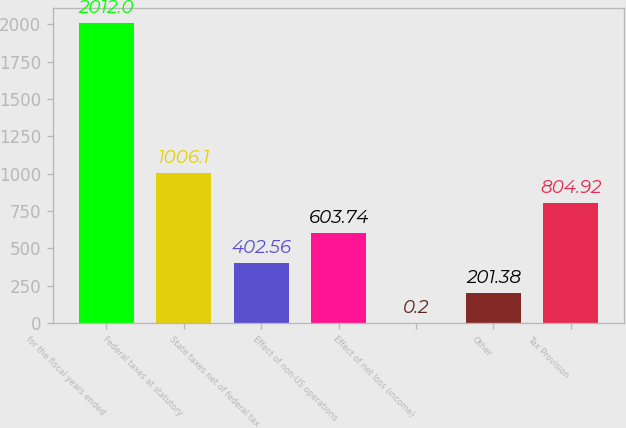Convert chart to OTSL. <chart><loc_0><loc_0><loc_500><loc_500><bar_chart><fcel>for the fiscal years ended<fcel>Federal taxes at statutory<fcel>State taxes net of federal tax<fcel>Effect of non-US operations<fcel>Effect of net loss (income)<fcel>Other<fcel>Tax Provision<nl><fcel>2012<fcel>1006.1<fcel>402.56<fcel>603.74<fcel>0.2<fcel>201.38<fcel>804.92<nl></chart> 